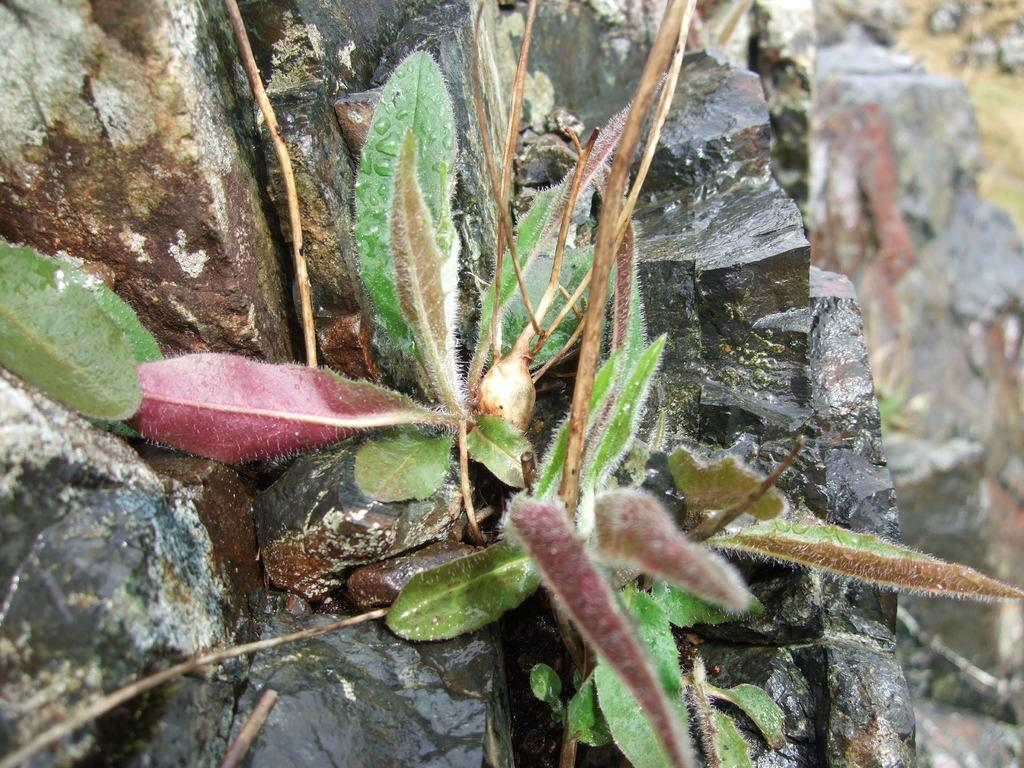What type of living organism can be seen in the image? There is a plant in the image. What non-living object is also present in the image? There is a rock in the image. What type of yarn is being used to create the plant in the image? There is no yarn present in the image; the plant is a living organism. What emotions can be observed in the rock in the image? Rocks do not have emotions, so it is not possible to observe any emotions in the rock. 